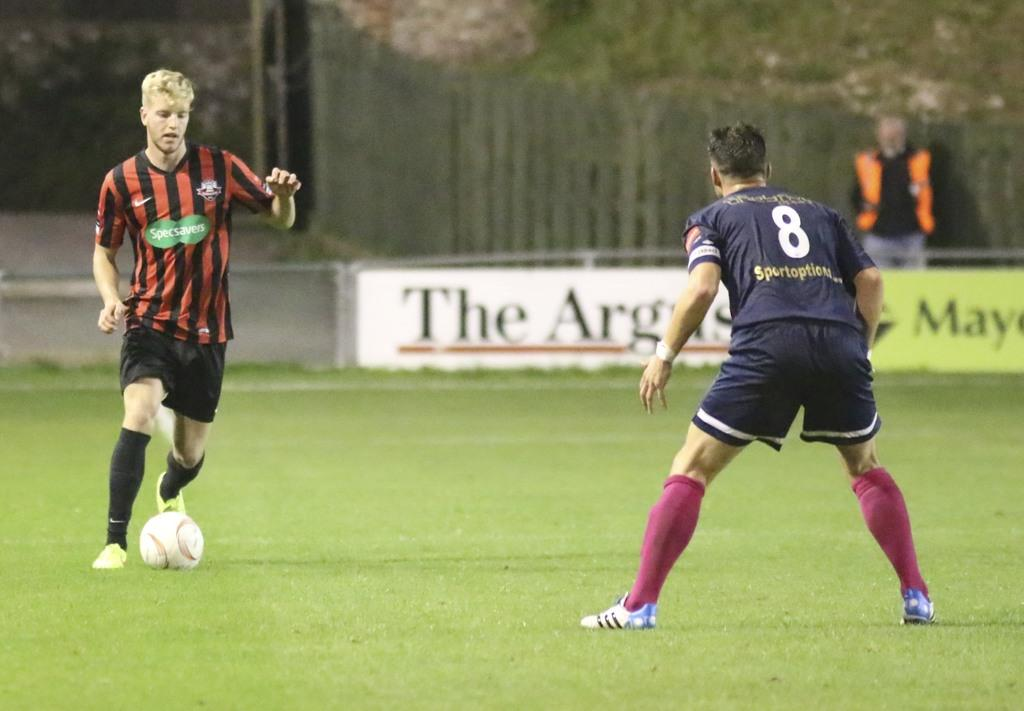<image>
Summarize the visual content of the image. Soccer player number 8 stands in a grass field facing an opposing player. 